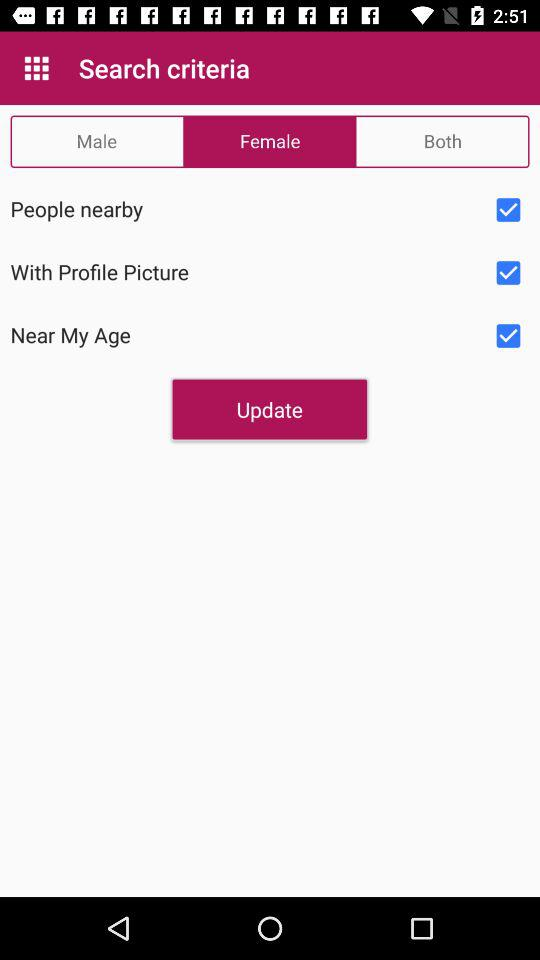Which tab is selected? The selected tab is "Female". 